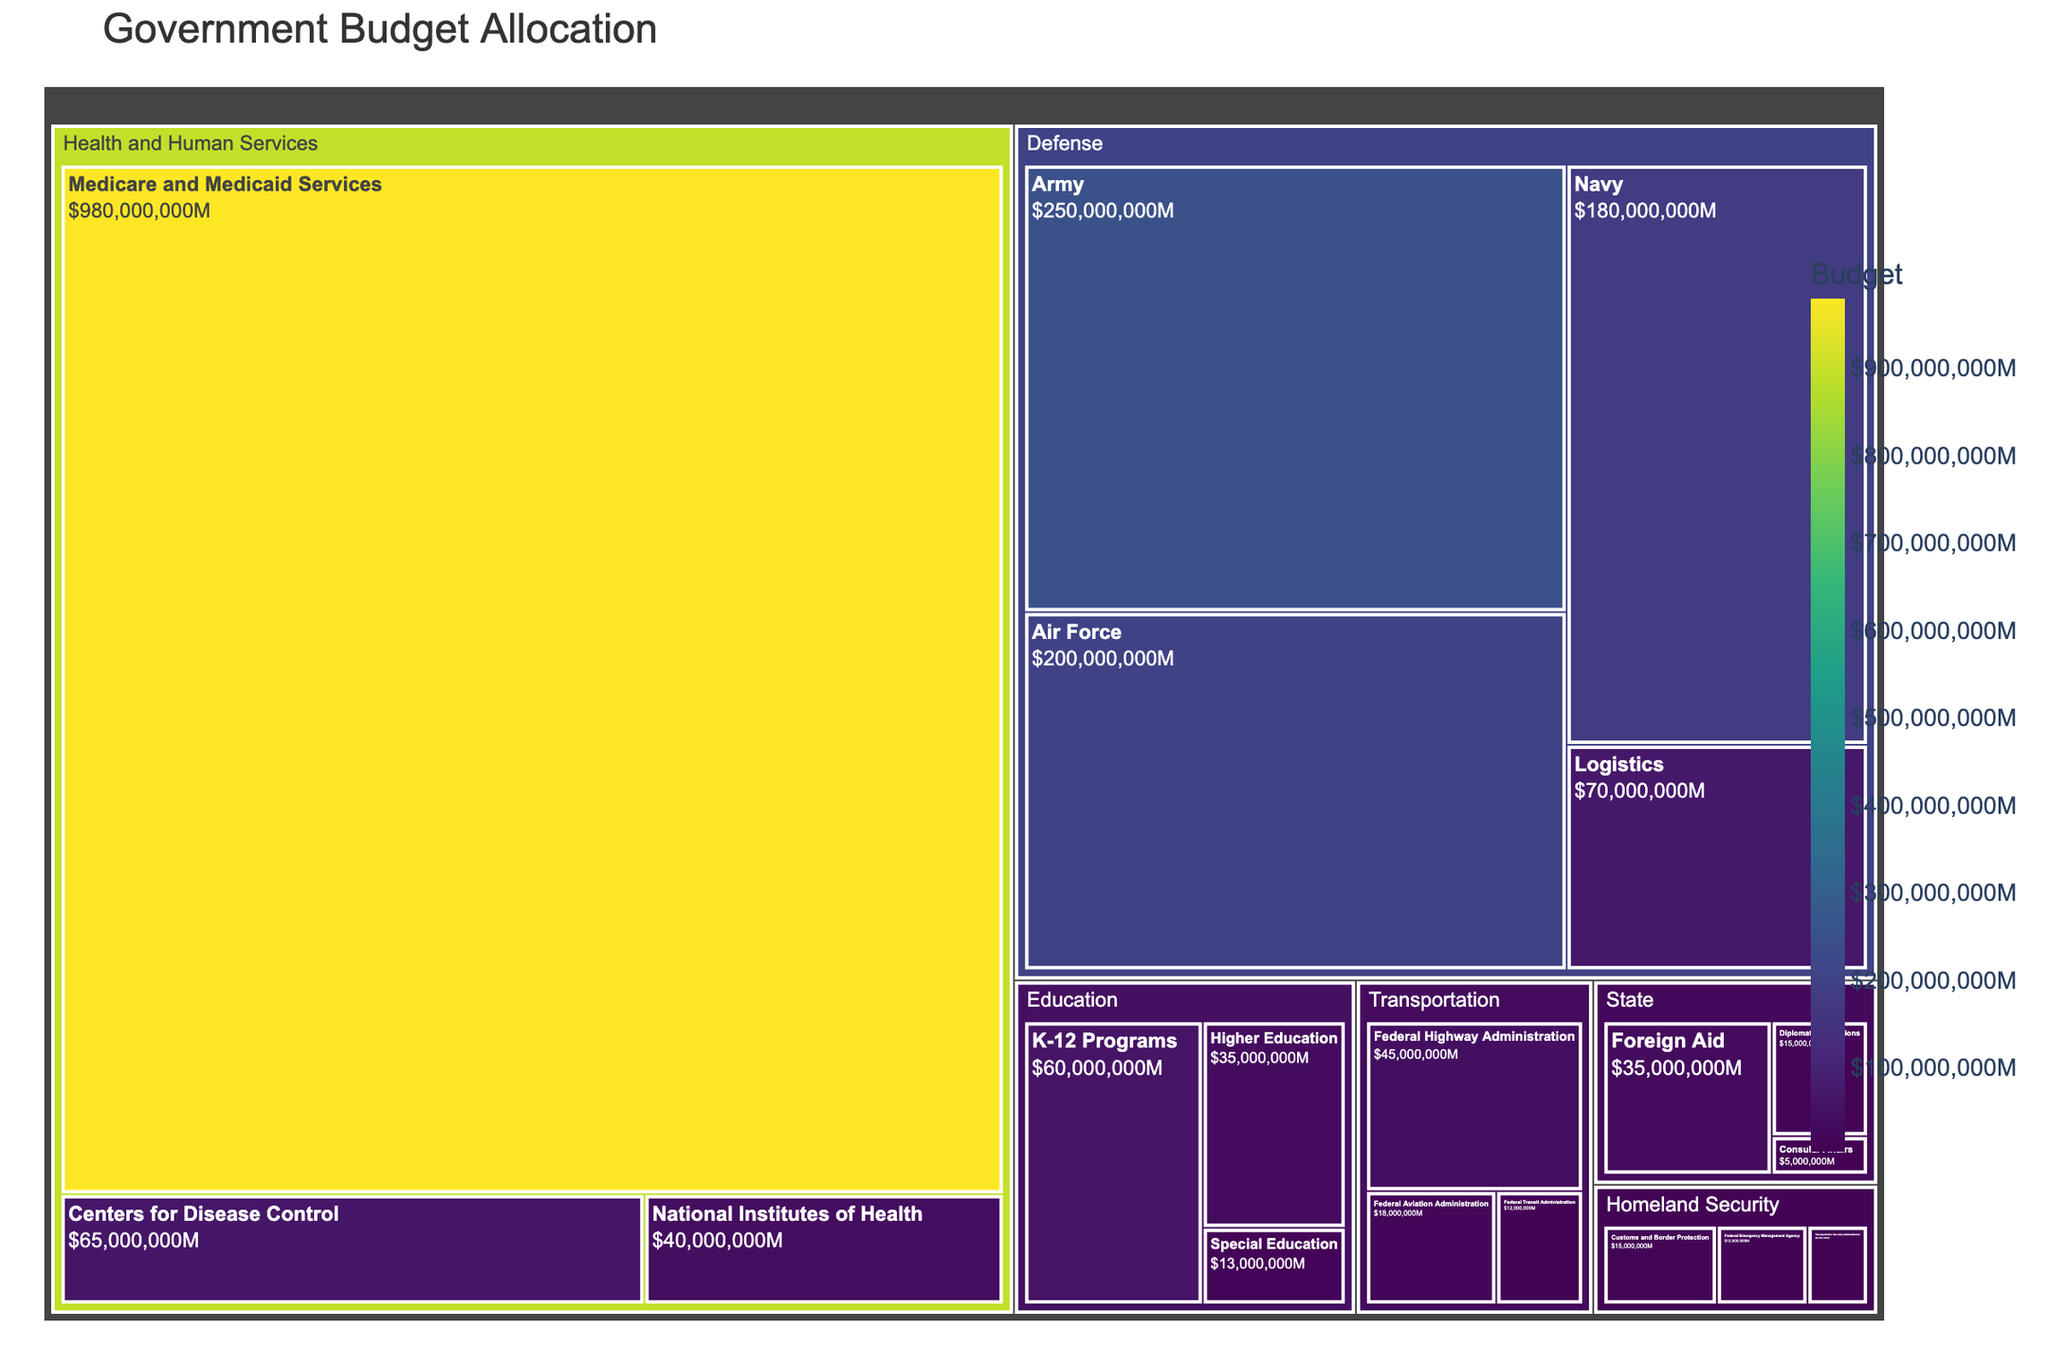What is the title of the treemap? The title is displayed at the top of the figure, providing a quick summary of what the figure represents.
Answer: Government Budget Allocation Which department has the highest budget allocation? By looking at the size and color of the sections, the largest and darkest section corresponds to the department with the highest budget allocation.
Answer: Health and Human Services What is the budget allocation for the Army sub-department? Locate the "Defense" segment in the treemap and find the "Army" sub-segment within it; the budget value is displayed.
Answer: $250,000,000 How much total budget is allocated to the Defense department? Sum up the budget values of all sub-departments under the "Defense" section: Army ($250M), Navy ($180M), Air Force ($200M), Logistics ($70M).
Answer: $700,000,000 Which sub-department in the Education department received the least budget allocation? Within the "Education" section, compare the sizes and labels of the sub-segments to identify the smallest one.
Answer: Special Education How does the budget for Customs and Border Protection compare to that of Diplomatic Operations? Find both sub-departments in their respective sections ("Homeland Security" and "State") and compare their budget values.
Answer: Customs and Border Protection has a lower budget ($15M vs $15M) If the budget of the National Institutes of Health is doubled, what will be the new total budget for the Health and Human Services department? Double the budget of NIH ($40M x 2 = $80M) and add the new value to other sub-department budgets: 65M (CDC) + 80M (NIH) + 980M (Medicare and Medicaid).
Answer: $1,125,000,000 Which two sub-departments have a budget difference closest to $5,000,000? Identify pairs of sub-departments and calculate the budget differences; the pair with the smallest deviation from $5,000,000 is the answer.
Answer: (Transportation Security Administration and Federal Emergency Management Agency; $8M and $12M) What is the average budget allocation among the sub-departments within the Transportation department? Sum the budgets of sub-departments under "Transportation" and divide by the number of sub-departments: (45M + 18M + 12M) / 3.
Answer: $25,000,000 Which department has the most sub-departments, and how many does it have? Count the number of sub-segments within each department and identify the department with the highest count.
Answer: Homeland Security, 3 